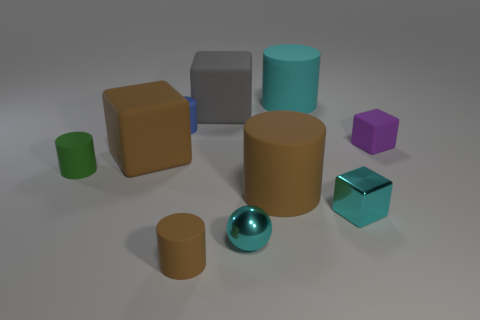Subtract all large cyan matte cylinders. How many cylinders are left? 4 Subtract all cyan blocks. How many blocks are left? 3 Subtract 1 balls. How many balls are left? 0 Subtract all blue spheres. How many red cylinders are left? 0 Subtract all brown balls. Subtract all cyan cylinders. How many balls are left? 1 Subtract all matte objects. Subtract all big gray cubes. How many objects are left? 1 Add 8 tiny cyan things. How many tiny cyan things are left? 10 Add 5 big blue rubber objects. How many big blue rubber objects exist? 5 Subtract 0 brown balls. How many objects are left? 10 Subtract all spheres. How many objects are left? 9 